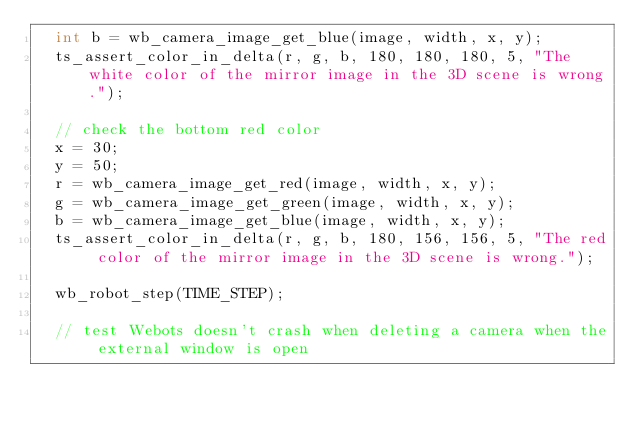<code> <loc_0><loc_0><loc_500><loc_500><_C_>  int b = wb_camera_image_get_blue(image, width, x, y);
  ts_assert_color_in_delta(r, g, b, 180, 180, 180, 5, "The white color of the mirror image in the 3D scene is wrong.");

  // check the bottom red color
  x = 30;
  y = 50;
  r = wb_camera_image_get_red(image, width, x, y);
  g = wb_camera_image_get_green(image, width, x, y);
  b = wb_camera_image_get_blue(image, width, x, y);
  ts_assert_color_in_delta(r, g, b, 180, 156, 156, 5, "The red color of the mirror image in the 3D scene is wrong.");

  wb_robot_step(TIME_STEP);

  // test Webots doesn't crash when deleting a camera when the external window is open</code> 